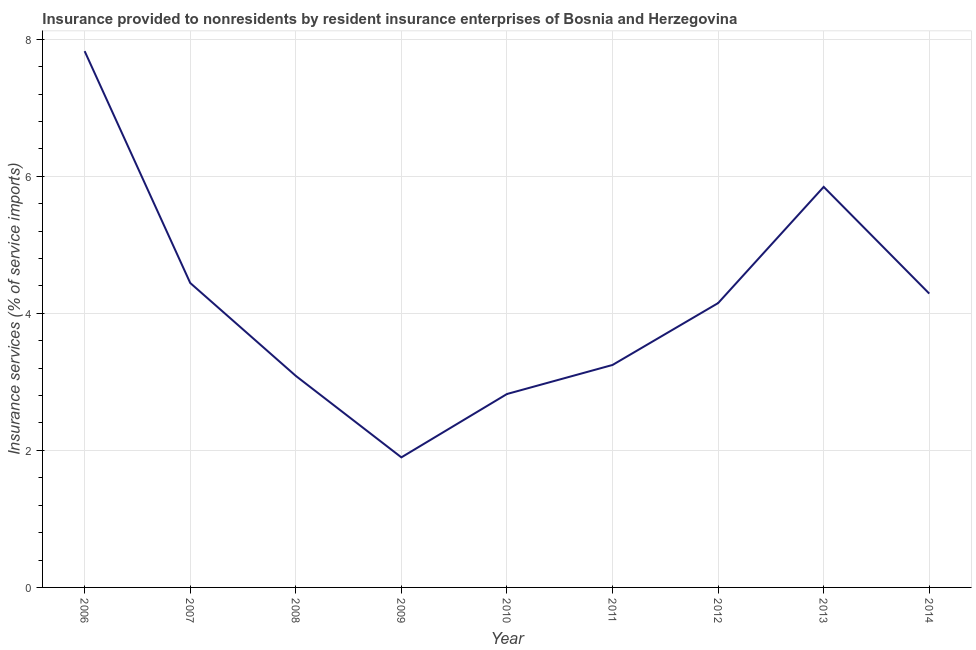What is the insurance and financial services in 2008?
Make the answer very short. 3.09. Across all years, what is the maximum insurance and financial services?
Ensure brevity in your answer.  7.83. Across all years, what is the minimum insurance and financial services?
Make the answer very short. 1.9. In which year was the insurance and financial services maximum?
Your answer should be very brief. 2006. In which year was the insurance and financial services minimum?
Your answer should be very brief. 2009. What is the sum of the insurance and financial services?
Give a very brief answer. 37.61. What is the difference between the insurance and financial services in 2006 and 2014?
Your answer should be very brief. 3.54. What is the average insurance and financial services per year?
Make the answer very short. 4.18. What is the median insurance and financial services?
Offer a very short reply. 4.15. In how many years, is the insurance and financial services greater than 2.8 %?
Your response must be concise. 8. Do a majority of the years between 2010 and 2006 (inclusive) have insurance and financial services greater than 3.2 %?
Your answer should be very brief. Yes. What is the ratio of the insurance and financial services in 2008 to that in 2010?
Provide a succinct answer. 1.09. Is the insurance and financial services in 2006 less than that in 2008?
Provide a short and direct response. No. Is the difference between the insurance and financial services in 2011 and 2013 greater than the difference between any two years?
Your answer should be compact. No. What is the difference between the highest and the second highest insurance and financial services?
Offer a terse response. 1.98. What is the difference between the highest and the lowest insurance and financial services?
Provide a short and direct response. 5.93. In how many years, is the insurance and financial services greater than the average insurance and financial services taken over all years?
Offer a very short reply. 4. Does the insurance and financial services monotonically increase over the years?
Give a very brief answer. No. How many lines are there?
Your response must be concise. 1. How many years are there in the graph?
Provide a short and direct response. 9. Does the graph contain any zero values?
Your answer should be compact. No. What is the title of the graph?
Offer a terse response. Insurance provided to nonresidents by resident insurance enterprises of Bosnia and Herzegovina. What is the label or title of the Y-axis?
Give a very brief answer. Insurance services (% of service imports). What is the Insurance services (% of service imports) in 2006?
Your response must be concise. 7.83. What is the Insurance services (% of service imports) of 2007?
Offer a terse response. 4.44. What is the Insurance services (% of service imports) in 2008?
Offer a very short reply. 3.09. What is the Insurance services (% of service imports) in 2009?
Your answer should be very brief. 1.9. What is the Insurance services (% of service imports) of 2010?
Make the answer very short. 2.82. What is the Insurance services (% of service imports) in 2011?
Your answer should be very brief. 3.25. What is the Insurance services (% of service imports) in 2012?
Keep it short and to the point. 4.15. What is the Insurance services (% of service imports) in 2013?
Provide a short and direct response. 5.85. What is the Insurance services (% of service imports) in 2014?
Your response must be concise. 4.29. What is the difference between the Insurance services (% of service imports) in 2006 and 2007?
Provide a succinct answer. 3.38. What is the difference between the Insurance services (% of service imports) in 2006 and 2008?
Your response must be concise. 4.74. What is the difference between the Insurance services (% of service imports) in 2006 and 2009?
Provide a short and direct response. 5.93. What is the difference between the Insurance services (% of service imports) in 2006 and 2010?
Provide a succinct answer. 5. What is the difference between the Insurance services (% of service imports) in 2006 and 2011?
Ensure brevity in your answer.  4.58. What is the difference between the Insurance services (% of service imports) in 2006 and 2012?
Your answer should be compact. 3.68. What is the difference between the Insurance services (% of service imports) in 2006 and 2013?
Provide a succinct answer. 1.98. What is the difference between the Insurance services (% of service imports) in 2006 and 2014?
Make the answer very short. 3.54. What is the difference between the Insurance services (% of service imports) in 2007 and 2008?
Make the answer very short. 1.36. What is the difference between the Insurance services (% of service imports) in 2007 and 2009?
Provide a succinct answer. 2.55. What is the difference between the Insurance services (% of service imports) in 2007 and 2010?
Provide a succinct answer. 1.62. What is the difference between the Insurance services (% of service imports) in 2007 and 2011?
Your response must be concise. 1.2. What is the difference between the Insurance services (% of service imports) in 2007 and 2012?
Keep it short and to the point. 0.29. What is the difference between the Insurance services (% of service imports) in 2007 and 2013?
Your response must be concise. -1.4. What is the difference between the Insurance services (% of service imports) in 2007 and 2014?
Your answer should be compact. 0.16. What is the difference between the Insurance services (% of service imports) in 2008 and 2009?
Offer a terse response. 1.19. What is the difference between the Insurance services (% of service imports) in 2008 and 2010?
Provide a succinct answer. 0.26. What is the difference between the Insurance services (% of service imports) in 2008 and 2011?
Provide a short and direct response. -0.16. What is the difference between the Insurance services (% of service imports) in 2008 and 2012?
Your answer should be compact. -1.06. What is the difference between the Insurance services (% of service imports) in 2008 and 2013?
Your answer should be compact. -2.76. What is the difference between the Insurance services (% of service imports) in 2008 and 2014?
Provide a short and direct response. -1.2. What is the difference between the Insurance services (% of service imports) in 2009 and 2010?
Give a very brief answer. -0.92. What is the difference between the Insurance services (% of service imports) in 2009 and 2011?
Your answer should be very brief. -1.35. What is the difference between the Insurance services (% of service imports) in 2009 and 2012?
Provide a short and direct response. -2.25. What is the difference between the Insurance services (% of service imports) in 2009 and 2013?
Give a very brief answer. -3.95. What is the difference between the Insurance services (% of service imports) in 2009 and 2014?
Your response must be concise. -2.39. What is the difference between the Insurance services (% of service imports) in 2010 and 2011?
Your answer should be compact. -0.42. What is the difference between the Insurance services (% of service imports) in 2010 and 2012?
Keep it short and to the point. -1.33. What is the difference between the Insurance services (% of service imports) in 2010 and 2013?
Give a very brief answer. -3.02. What is the difference between the Insurance services (% of service imports) in 2010 and 2014?
Keep it short and to the point. -1.47. What is the difference between the Insurance services (% of service imports) in 2011 and 2012?
Offer a terse response. -0.9. What is the difference between the Insurance services (% of service imports) in 2011 and 2013?
Offer a terse response. -2.6. What is the difference between the Insurance services (% of service imports) in 2011 and 2014?
Your answer should be compact. -1.04. What is the difference between the Insurance services (% of service imports) in 2012 and 2013?
Offer a very short reply. -1.7. What is the difference between the Insurance services (% of service imports) in 2012 and 2014?
Provide a succinct answer. -0.14. What is the difference between the Insurance services (% of service imports) in 2013 and 2014?
Ensure brevity in your answer.  1.56. What is the ratio of the Insurance services (% of service imports) in 2006 to that in 2007?
Give a very brief answer. 1.76. What is the ratio of the Insurance services (% of service imports) in 2006 to that in 2008?
Provide a short and direct response. 2.54. What is the ratio of the Insurance services (% of service imports) in 2006 to that in 2009?
Keep it short and to the point. 4.12. What is the ratio of the Insurance services (% of service imports) in 2006 to that in 2010?
Ensure brevity in your answer.  2.77. What is the ratio of the Insurance services (% of service imports) in 2006 to that in 2011?
Your answer should be very brief. 2.41. What is the ratio of the Insurance services (% of service imports) in 2006 to that in 2012?
Provide a succinct answer. 1.89. What is the ratio of the Insurance services (% of service imports) in 2006 to that in 2013?
Offer a very short reply. 1.34. What is the ratio of the Insurance services (% of service imports) in 2006 to that in 2014?
Provide a succinct answer. 1.82. What is the ratio of the Insurance services (% of service imports) in 2007 to that in 2008?
Ensure brevity in your answer.  1.44. What is the ratio of the Insurance services (% of service imports) in 2007 to that in 2009?
Keep it short and to the point. 2.34. What is the ratio of the Insurance services (% of service imports) in 2007 to that in 2010?
Provide a short and direct response. 1.57. What is the ratio of the Insurance services (% of service imports) in 2007 to that in 2011?
Your answer should be very brief. 1.37. What is the ratio of the Insurance services (% of service imports) in 2007 to that in 2012?
Your answer should be very brief. 1.07. What is the ratio of the Insurance services (% of service imports) in 2007 to that in 2013?
Your answer should be very brief. 0.76. What is the ratio of the Insurance services (% of service imports) in 2007 to that in 2014?
Ensure brevity in your answer.  1.04. What is the ratio of the Insurance services (% of service imports) in 2008 to that in 2009?
Give a very brief answer. 1.63. What is the ratio of the Insurance services (% of service imports) in 2008 to that in 2010?
Offer a terse response. 1.09. What is the ratio of the Insurance services (% of service imports) in 2008 to that in 2011?
Offer a terse response. 0.95. What is the ratio of the Insurance services (% of service imports) in 2008 to that in 2012?
Provide a short and direct response. 0.74. What is the ratio of the Insurance services (% of service imports) in 2008 to that in 2013?
Offer a terse response. 0.53. What is the ratio of the Insurance services (% of service imports) in 2008 to that in 2014?
Provide a succinct answer. 0.72. What is the ratio of the Insurance services (% of service imports) in 2009 to that in 2010?
Your response must be concise. 0.67. What is the ratio of the Insurance services (% of service imports) in 2009 to that in 2011?
Give a very brief answer. 0.58. What is the ratio of the Insurance services (% of service imports) in 2009 to that in 2012?
Your answer should be very brief. 0.46. What is the ratio of the Insurance services (% of service imports) in 2009 to that in 2013?
Your response must be concise. 0.33. What is the ratio of the Insurance services (% of service imports) in 2009 to that in 2014?
Provide a short and direct response. 0.44. What is the ratio of the Insurance services (% of service imports) in 2010 to that in 2011?
Ensure brevity in your answer.  0.87. What is the ratio of the Insurance services (% of service imports) in 2010 to that in 2012?
Offer a very short reply. 0.68. What is the ratio of the Insurance services (% of service imports) in 2010 to that in 2013?
Give a very brief answer. 0.48. What is the ratio of the Insurance services (% of service imports) in 2010 to that in 2014?
Provide a succinct answer. 0.66. What is the ratio of the Insurance services (% of service imports) in 2011 to that in 2012?
Ensure brevity in your answer.  0.78. What is the ratio of the Insurance services (% of service imports) in 2011 to that in 2013?
Your answer should be very brief. 0.56. What is the ratio of the Insurance services (% of service imports) in 2011 to that in 2014?
Give a very brief answer. 0.76. What is the ratio of the Insurance services (% of service imports) in 2012 to that in 2013?
Provide a short and direct response. 0.71. What is the ratio of the Insurance services (% of service imports) in 2012 to that in 2014?
Ensure brevity in your answer.  0.97. What is the ratio of the Insurance services (% of service imports) in 2013 to that in 2014?
Give a very brief answer. 1.36. 